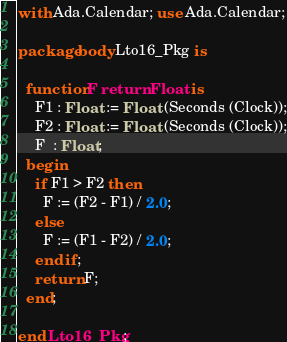Convert code to text. <code><loc_0><loc_0><loc_500><loc_500><_Ada_>with Ada.Calendar; use Ada.Calendar;

package body Lto16_Pkg is

  function F return Float is
    F1 : Float := Float (Seconds (Clock));
    F2 : Float := Float (Seconds (Clock));
    F  : Float;
  begin
    if F1 > F2 then
      F := (F2 - F1) / 2.0;
    else
      F := (F1 - F2) / 2.0;
    end if;
    return F;
  end;

end Lto16_Pkg;
</code> 